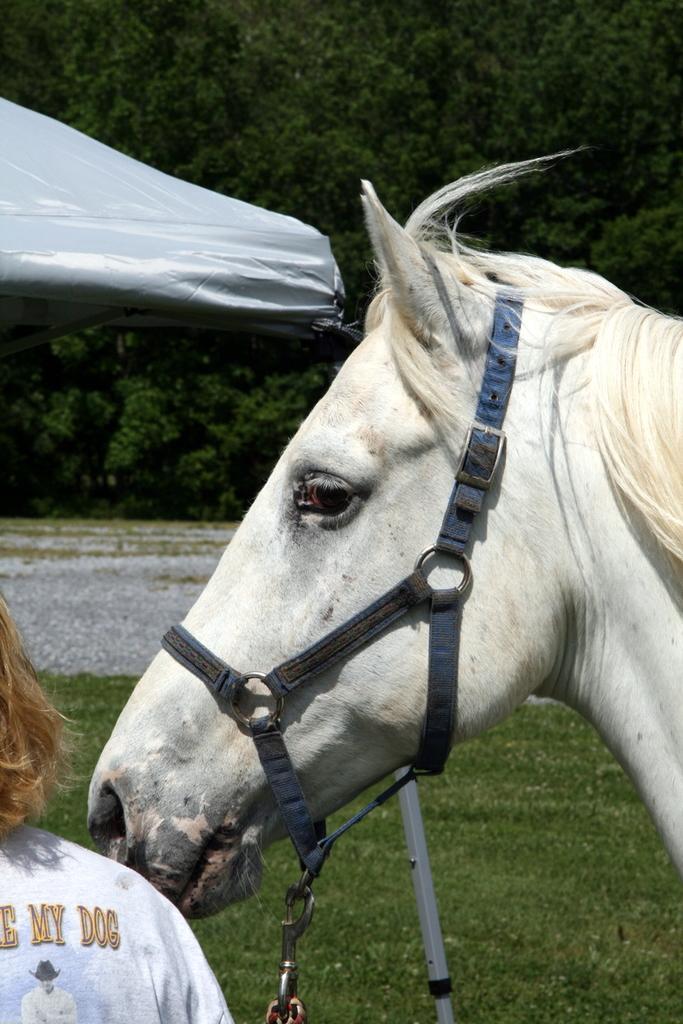Describe this image in one or two sentences. In this picture, we see a white horse. The mane of the horse is also in white color. We can only see eye, ear, nose and mouth of the horse. In the left bottom, we see a woman in white T-shirt is standing. At the bottom, we see the grass. In the background, we see a white tent, small stones and trees. 